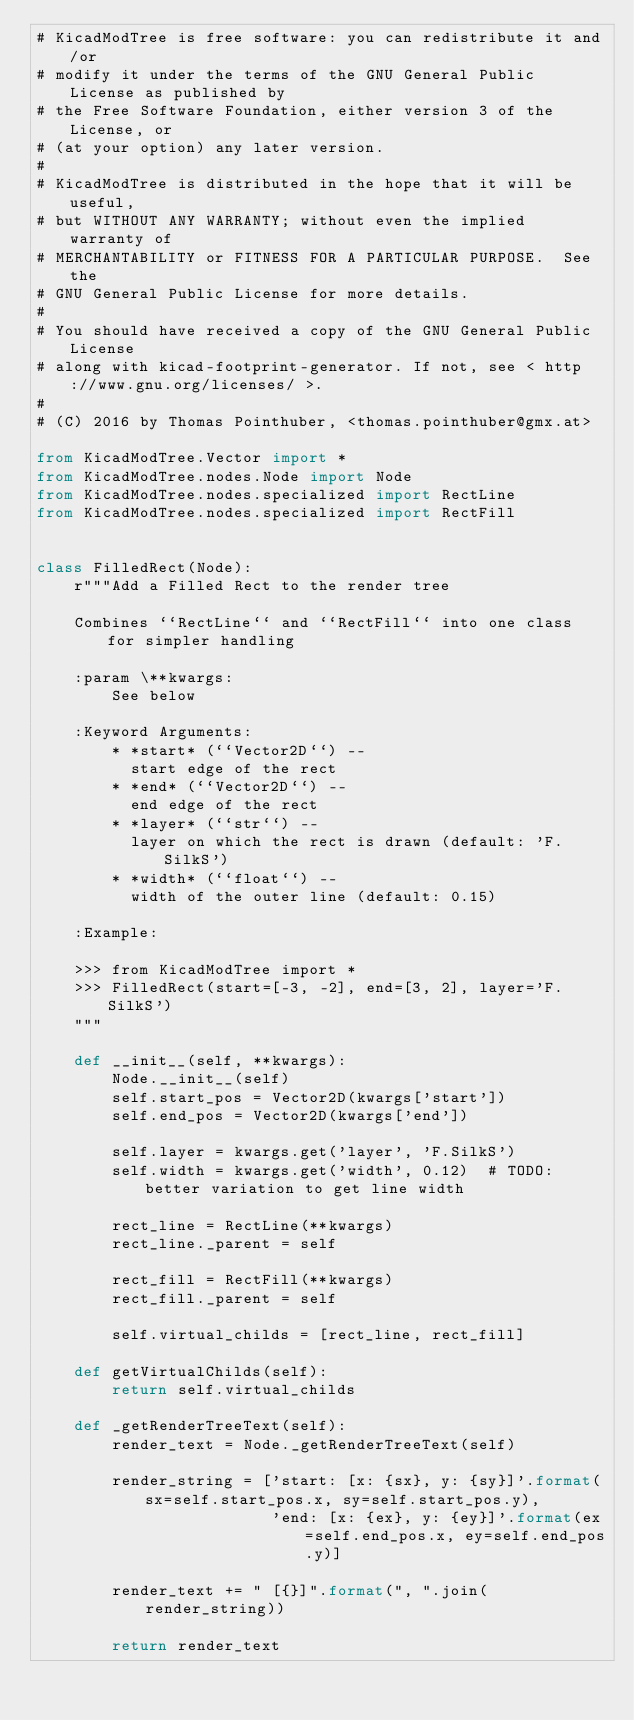Convert code to text. <code><loc_0><loc_0><loc_500><loc_500><_Python_># KicadModTree is free software: you can redistribute it and/or
# modify it under the terms of the GNU General Public License as published by
# the Free Software Foundation, either version 3 of the License, or
# (at your option) any later version.
#
# KicadModTree is distributed in the hope that it will be useful,
# but WITHOUT ANY WARRANTY; without even the implied warranty of
# MERCHANTABILITY or FITNESS FOR A PARTICULAR PURPOSE.  See the
# GNU General Public License for more details.
#
# You should have received a copy of the GNU General Public License
# along with kicad-footprint-generator. If not, see < http://www.gnu.org/licenses/ >.
#
# (C) 2016 by Thomas Pointhuber, <thomas.pointhuber@gmx.at>

from KicadModTree.Vector import *
from KicadModTree.nodes.Node import Node
from KicadModTree.nodes.specialized import RectLine
from KicadModTree.nodes.specialized import RectFill


class FilledRect(Node):
    r"""Add a Filled Rect to the render tree

    Combines ``RectLine`` and ``RectFill`` into one class for simpler handling

    :param \**kwargs:
        See below

    :Keyword Arguments:
        * *start* (``Vector2D``) --
          start edge of the rect
        * *end* (``Vector2D``) --
          end edge of the rect
        * *layer* (``str``) --
          layer on which the rect is drawn (default: 'F.SilkS')
        * *width* (``float``) --
          width of the outer line (default: 0.15)

    :Example:

    >>> from KicadModTree import *
    >>> FilledRect(start=[-3, -2], end=[3, 2], layer='F.SilkS')
    """

    def __init__(self, **kwargs):
        Node.__init__(self)
        self.start_pos = Vector2D(kwargs['start'])
        self.end_pos = Vector2D(kwargs['end'])

        self.layer = kwargs.get('layer', 'F.SilkS')
        self.width = kwargs.get('width', 0.12)  # TODO: better variation to get line width

        rect_line = RectLine(**kwargs)
        rect_line._parent = self

        rect_fill = RectFill(**kwargs)
        rect_fill._parent = self

        self.virtual_childs = [rect_line, rect_fill]

    def getVirtualChilds(self):
        return self.virtual_childs

    def _getRenderTreeText(self):
        render_text = Node._getRenderTreeText(self)

        render_string = ['start: [x: {sx}, y: {sy}]'.format(sx=self.start_pos.x, sy=self.start_pos.y),
                         'end: [x: {ex}, y: {ey}]'.format(ex=self.end_pos.x, ey=self.end_pos.y)]

        render_text += " [{}]".format(", ".join(render_string))

        return render_text
</code> 